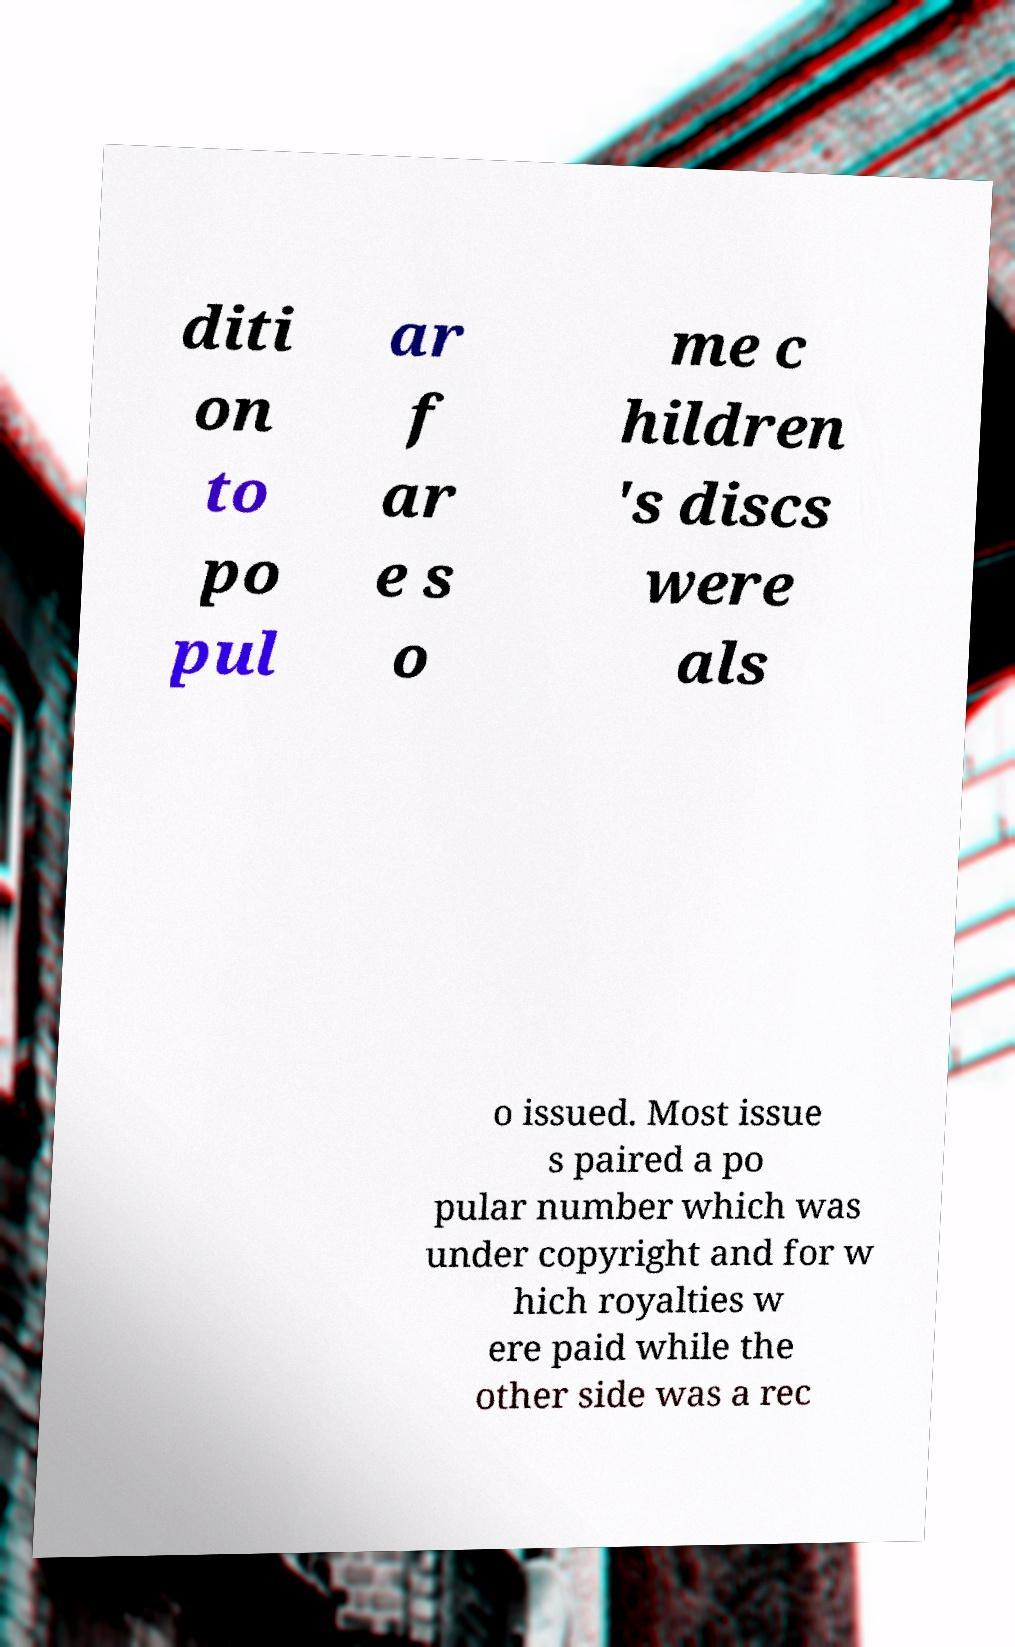For documentation purposes, I need the text within this image transcribed. Could you provide that? diti on to po pul ar f ar e s o me c hildren 's discs were als o issued. Most issue s paired a po pular number which was under copyright and for w hich royalties w ere paid while the other side was a rec 